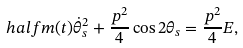Convert formula to latex. <formula><loc_0><loc_0><loc_500><loc_500>\ h a l f m ( t ) \dot { \theta } _ { s } ^ { 2 } + \frac { p ^ { 2 } } { 4 } \cos 2 \theta _ { s } = \frac { p ^ { 2 } } { 4 } E ,</formula> 